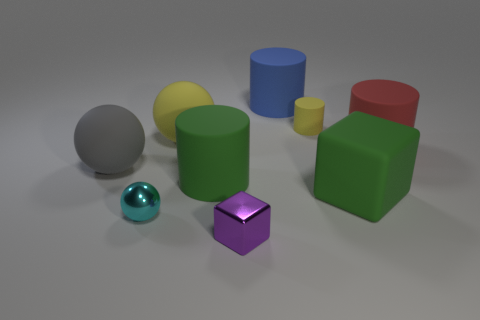Subtract all green cylinders. How many cylinders are left? 3 Subtract all blue rubber cylinders. How many cylinders are left? 3 Add 1 yellow rubber balls. How many objects exist? 10 Subtract all cyan cylinders. Subtract all red spheres. How many cylinders are left? 4 Subtract all blocks. How many objects are left? 7 Subtract all tiny brown metal cubes. Subtract all large rubber objects. How many objects are left? 3 Add 3 small purple blocks. How many small purple blocks are left? 4 Add 5 cubes. How many cubes exist? 7 Subtract 1 gray balls. How many objects are left? 8 